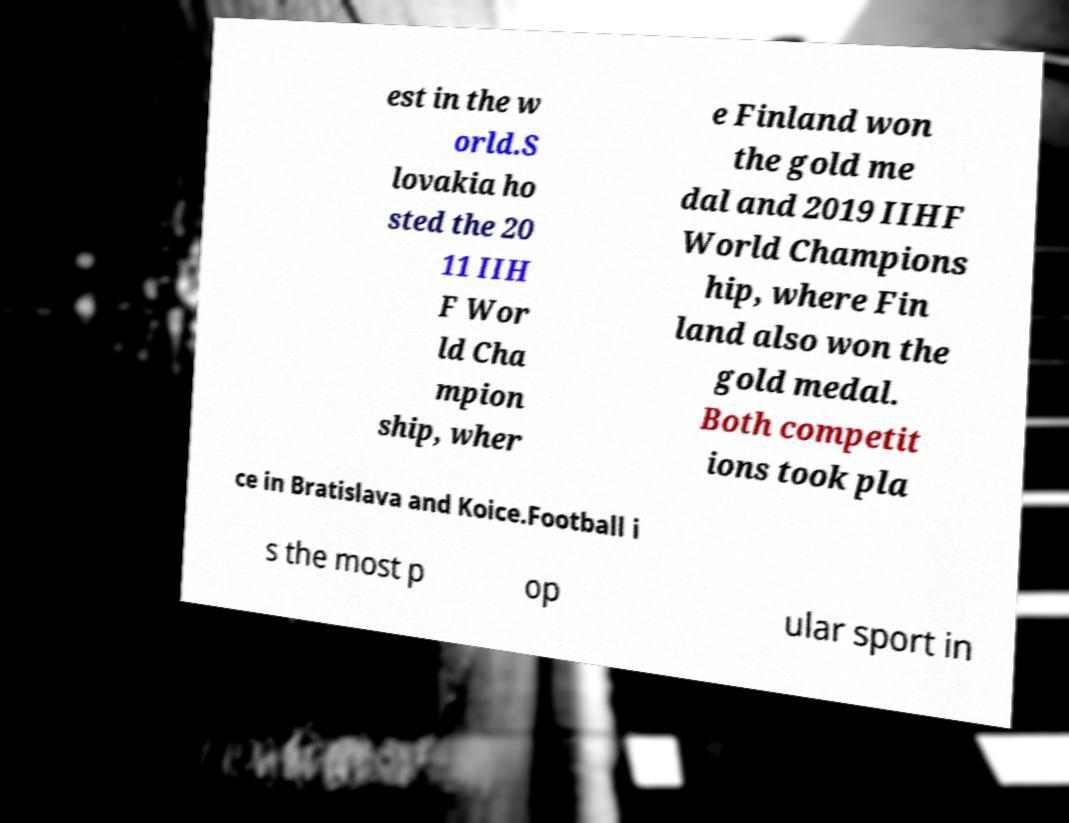Please identify and transcribe the text found in this image. est in the w orld.S lovakia ho sted the 20 11 IIH F Wor ld Cha mpion ship, wher e Finland won the gold me dal and 2019 IIHF World Champions hip, where Fin land also won the gold medal. Both competit ions took pla ce in Bratislava and Koice.Football i s the most p op ular sport in 